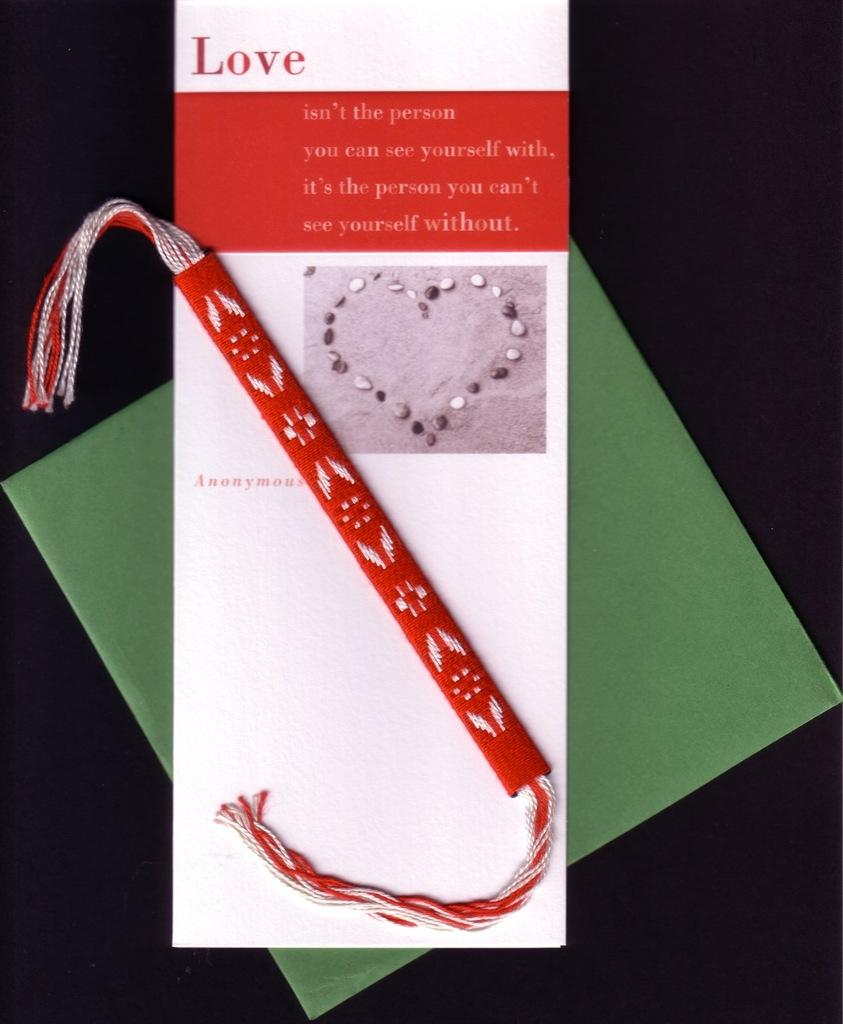What is the main object in the image? There is a rakhi band in the image. What is the color of the rakhi band? The rakhi band is red in color. What other item can be seen in the image? There is a greeting card in the image. What is written on the greeting card? The greeting card has something written on it. How are the rakhi band and greeting card arranged in the image? The greeting card is placed below the rakhi band. What is the most efficient route to take while walking on the side of the rakhi band in the image? There is no need to walk on the side of the rakhi band in the image, as it is a stationary object. What type of system is used to create the rakhi band in the image? The image does not provide information about the manufacturing process or system used to create the rakhi band. 